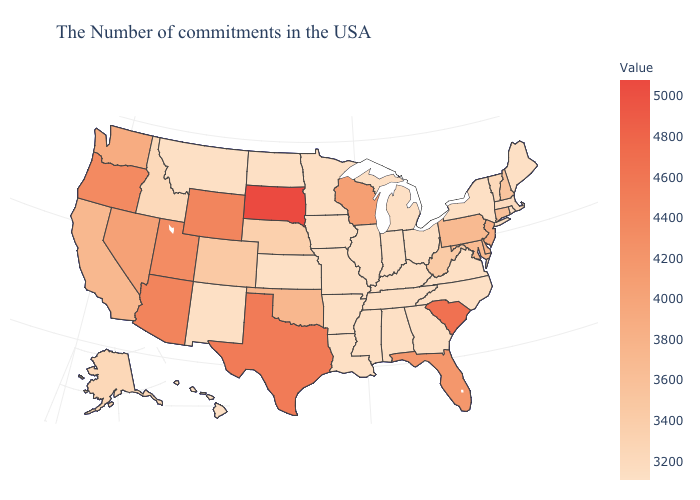Does Massachusetts have a lower value than New Jersey?
Short answer required. Yes. Does Oklahoma have a higher value than South Dakota?
Give a very brief answer. No. Does New York have the highest value in the Northeast?
Short answer required. No. Among the states that border Maryland , which have the highest value?
Be succinct. Delaware. Among the states that border Connecticut , does Massachusetts have the lowest value?
Quick response, please. No. Which states have the lowest value in the USA?
Concise answer only. Maine, Rhode Island, New York, Virginia, North Carolina, Ohio, Georgia, Michigan, Kentucky, Indiana, Alabama, Tennessee, Illinois, Mississippi, Louisiana, Missouri, Arkansas, Minnesota, Iowa, Kansas, North Dakota, New Mexico, Montana, Hawaii. Does New Mexico have the highest value in the West?
Write a very short answer. No. Does Arizona have the highest value in the West?
Give a very brief answer. Yes. 